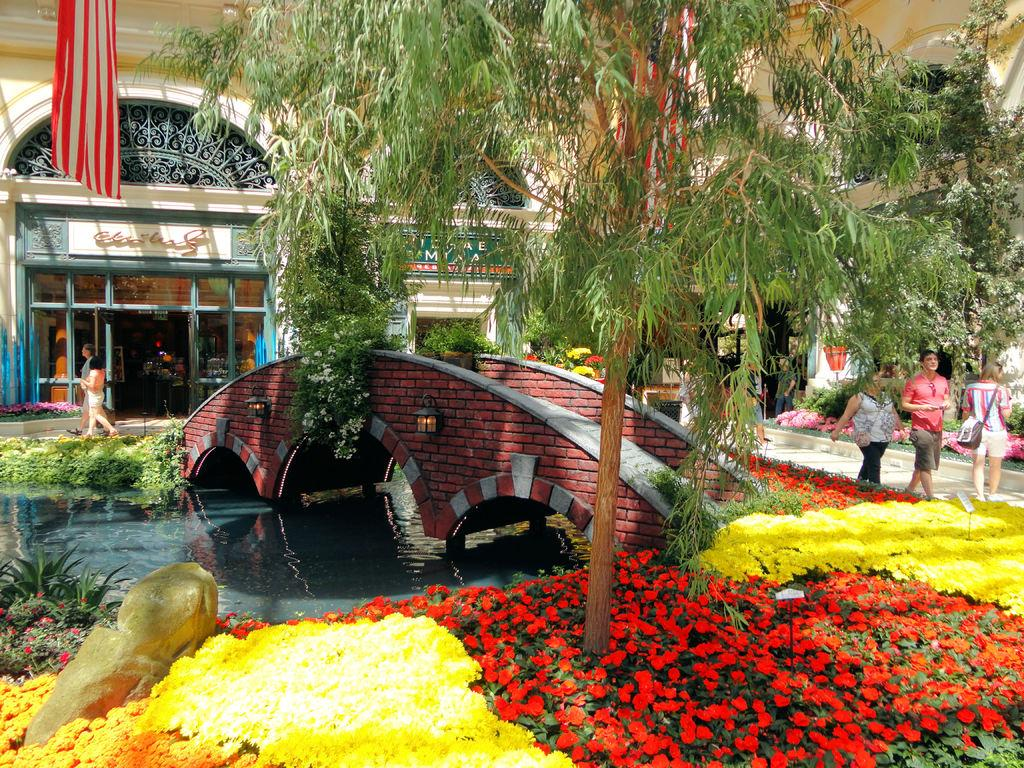What type of outdoor space is shown in the image? There is a garden in the image. What natural element can be seen in the garden? There is a tree in the image. What man-made structure is present in the garden? There is a bridge in the image. What type of building is visible in the image? There is a building in the image. What are the people in the garden doing? Three people are walking in the garden. What can be seen on the left side of the image? Water is present on the left side of the image. What type of sign can be seen on the tree in the image? There is no sign present on the tree in the image. What kind of carpenter is working on the bridge in the image? There is no carpenter present in the image, nor is there any indication of construction or repair work on the bridge. 